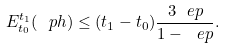Convert formula to latex. <formula><loc_0><loc_0><loc_500><loc_500>E _ { t _ { 0 } } ^ { t _ { 1 } } ( \ p h ) \leq ( t _ { 1 } - t _ { 0 } ) \frac { 3 \ e p } { 1 - \ e p } .</formula> 